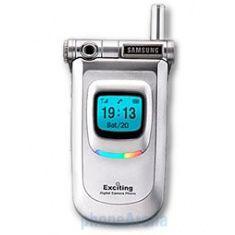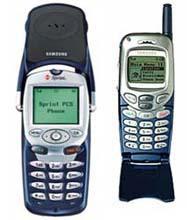The first image is the image on the left, the second image is the image on the right. Examine the images to the left and right. Is the description "There are more phones in the image on the right." accurate? Answer yes or no. Yes. The first image is the image on the left, the second image is the image on the right. For the images shown, is this caption "The right image shows an opened flip phone." true? Answer yes or no. No. 